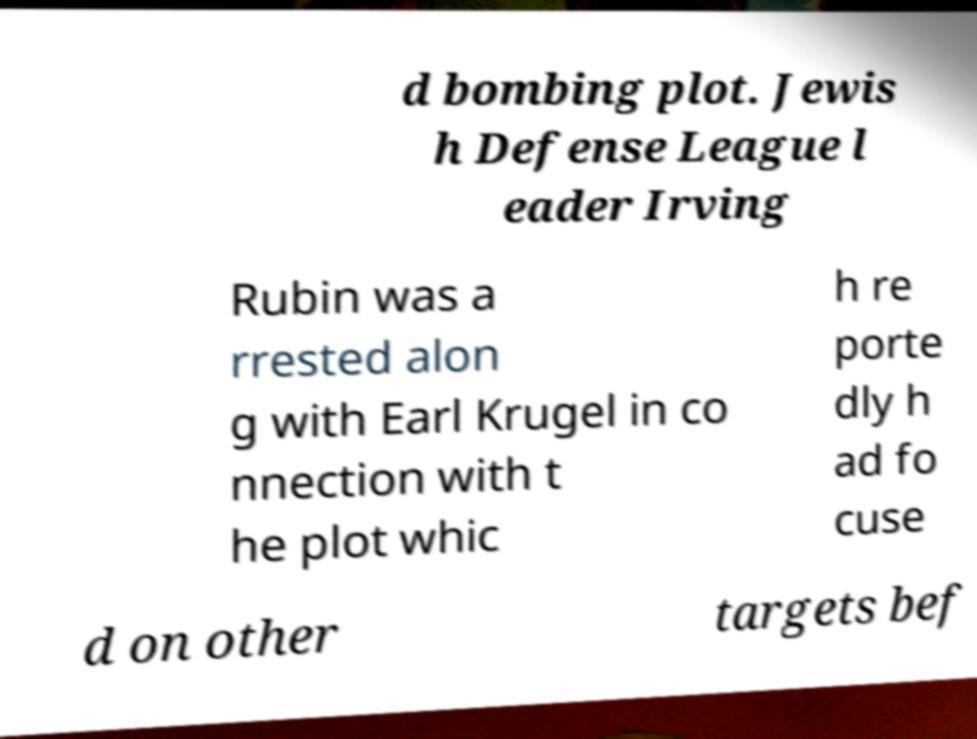There's text embedded in this image that I need extracted. Can you transcribe it verbatim? d bombing plot. Jewis h Defense League l eader Irving Rubin was a rrested alon g with Earl Krugel in co nnection with t he plot whic h re porte dly h ad fo cuse d on other targets bef 